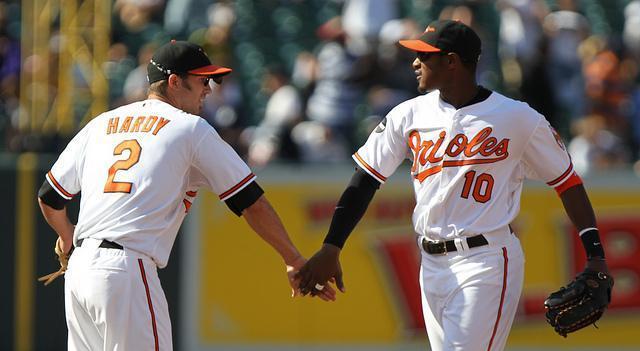How many people are there?
Give a very brief answer. 3. How many people at the table are wearing tie dye?
Give a very brief answer. 0. 